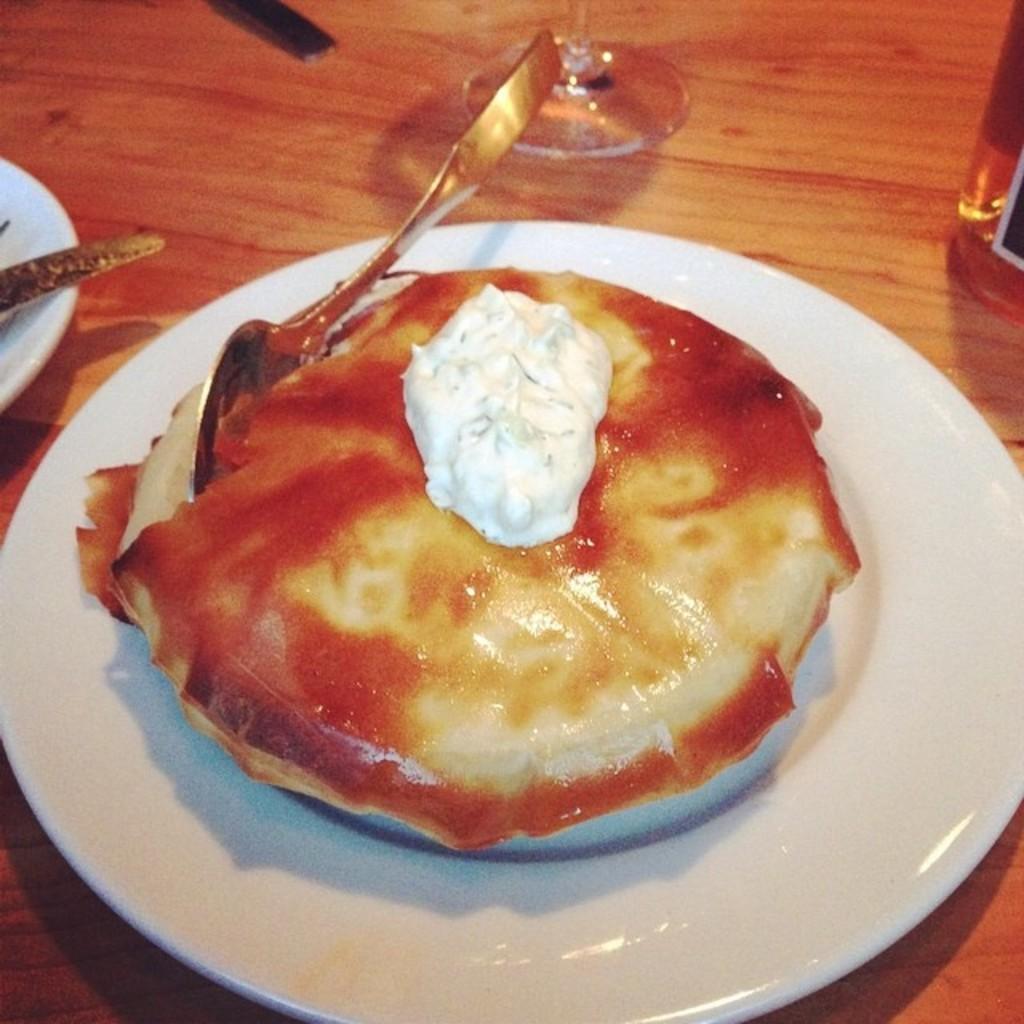Could you give a brief overview of what you see in this image? In this image we can see baked goods such as cake are in plate and placed on the table holding one spoon on it. And we can see one glass below part. And surrounding we can see many plates having eatables. 